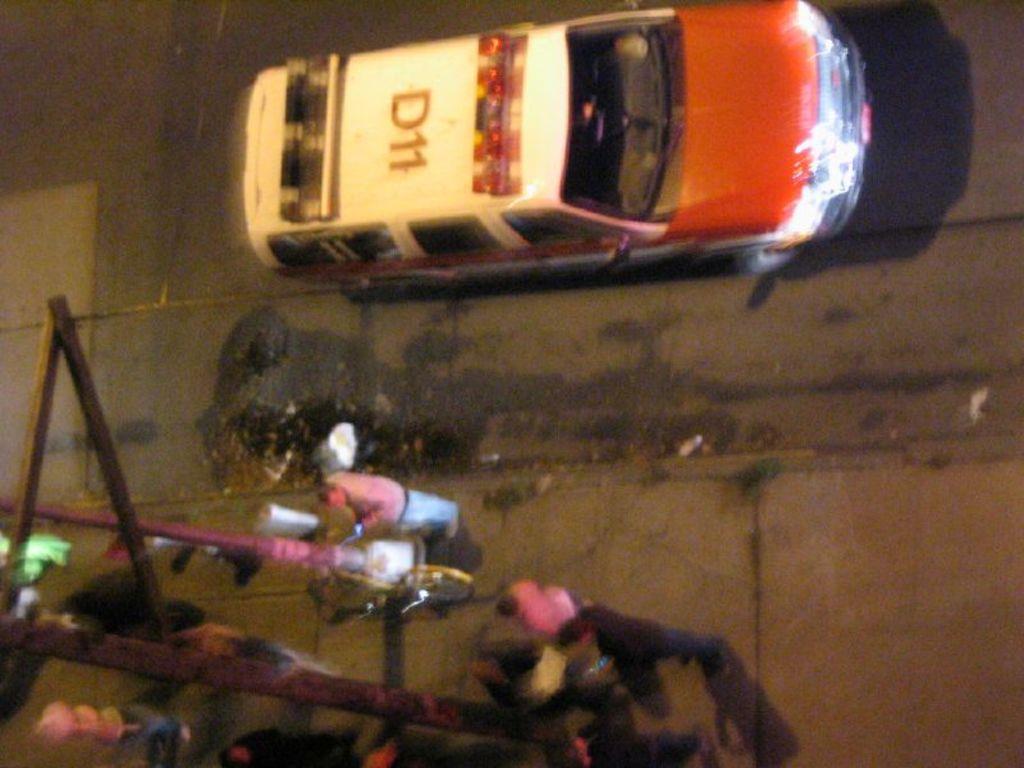Can you describe this image briefly? In the image in the center we can see few vehicles on the road. And we can see poles and few people were standing. 